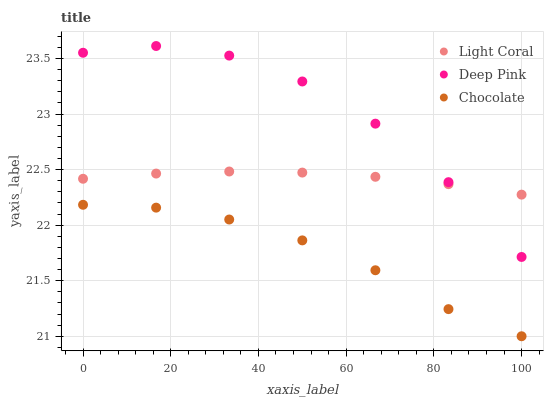Does Chocolate have the minimum area under the curve?
Answer yes or no. Yes. Does Deep Pink have the maximum area under the curve?
Answer yes or no. Yes. Does Deep Pink have the minimum area under the curve?
Answer yes or no. No. Does Chocolate have the maximum area under the curve?
Answer yes or no. No. Is Light Coral the smoothest?
Answer yes or no. Yes. Is Deep Pink the roughest?
Answer yes or no. Yes. Is Chocolate the smoothest?
Answer yes or no. No. Is Chocolate the roughest?
Answer yes or no. No. Does Chocolate have the lowest value?
Answer yes or no. Yes. Does Deep Pink have the lowest value?
Answer yes or no. No. Does Deep Pink have the highest value?
Answer yes or no. Yes. Does Chocolate have the highest value?
Answer yes or no. No. Is Chocolate less than Light Coral?
Answer yes or no. Yes. Is Deep Pink greater than Chocolate?
Answer yes or no. Yes. Does Light Coral intersect Deep Pink?
Answer yes or no. Yes. Is Light Coral less than Deep Pink?
Answer yes or no. No. Is Light Coral greater than Deep Pink?
Answer yes or no. No. Does Chocolate intersect Light Coral?
Answer yes or no. No. 